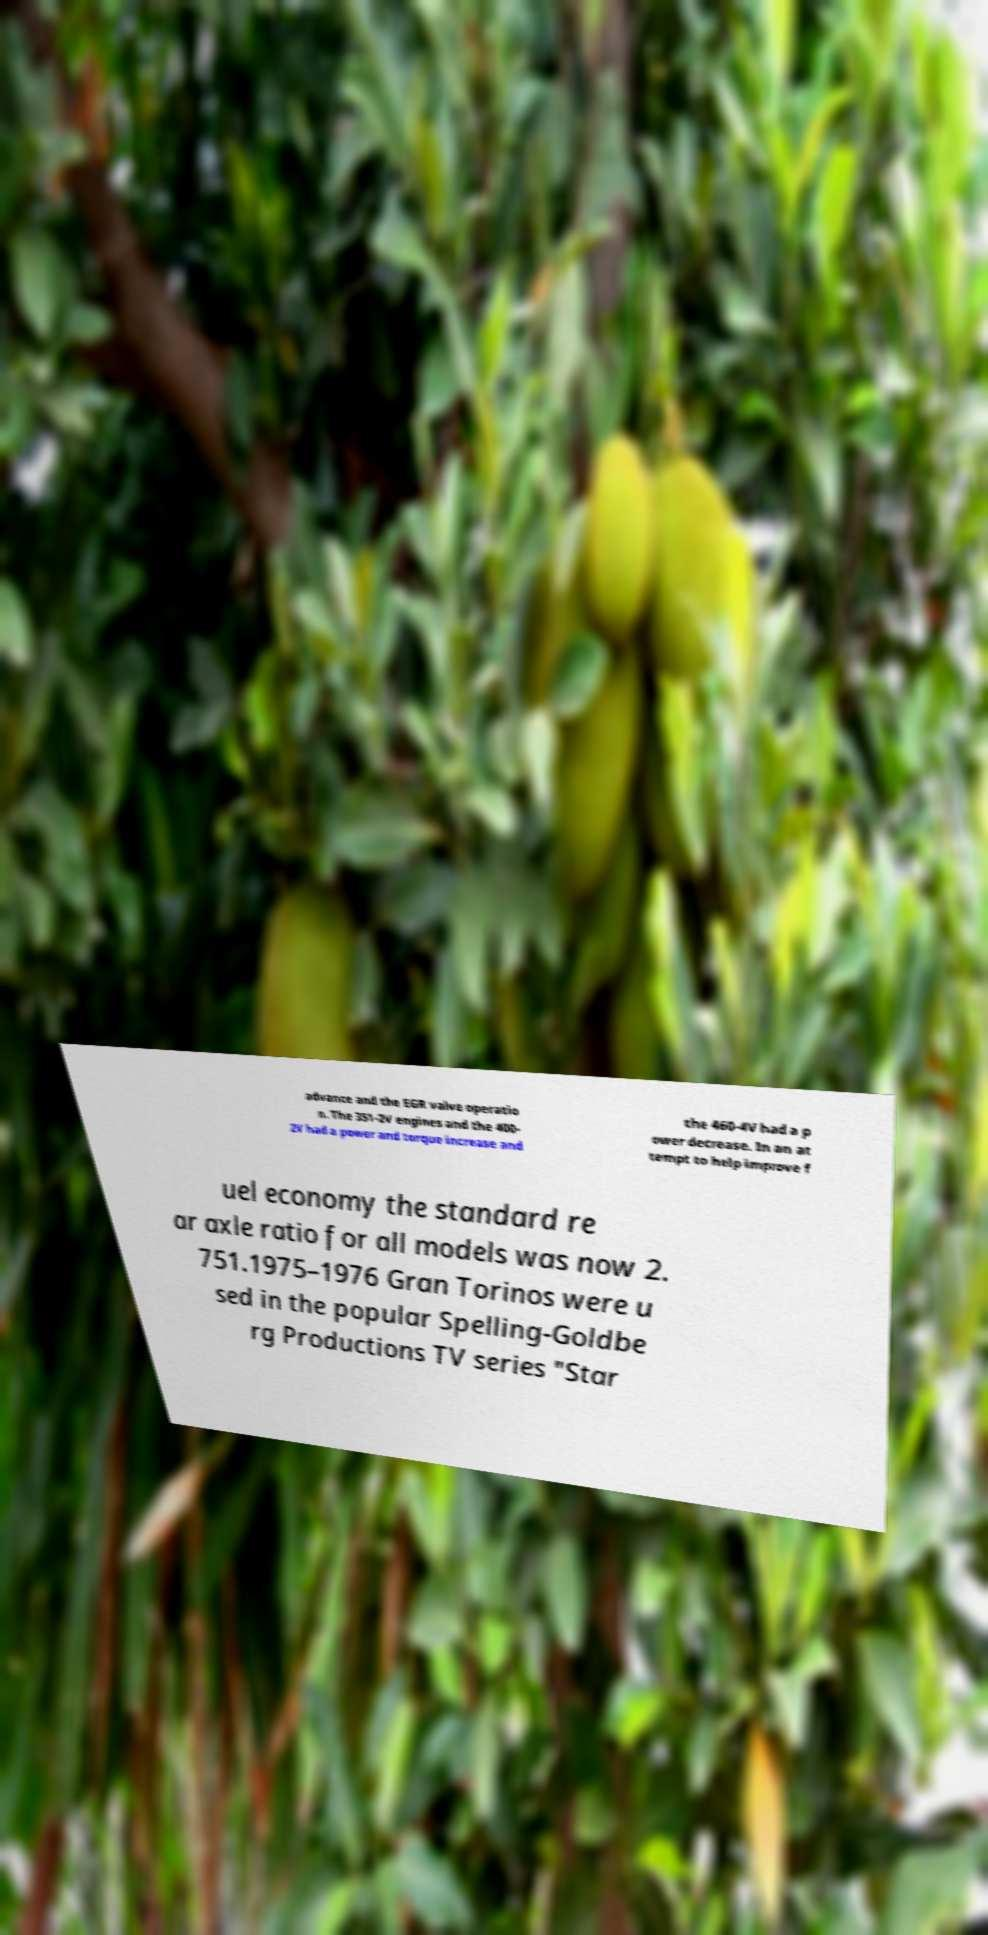What messages or text are displayed in this image? I need them in a readable, typed format. advance and the EGR valve operatio n. The 351-2V engines and the 400- 2V had a power and torque increase and the 460-4V had a p ower decrease. In an at tempt to help improve f uel economy the standard re ar axle ratio for all models was now 2. 751.1975–1976 Gran Torinos were u sed in the popular Spelling-Goldbe rg Productions TV series "Star 